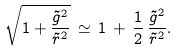<formula> <loc_0><loc_0><loc_500><loc_500>\sqrt { 1 + \frac { \tilde { g } ^ { 2 } } { \tilde { r } ^ { 2 } } } \, \simeq \, 1 \, + \, \frac { 1 } { 2 } \, \frac { \tilde { g } ^ { 2 } } { \tilde { r } ^ { 2 } } .</formula> 